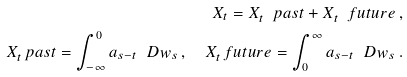<formula> <loc_0><loc_0><loc_500><loc_500>X _ { t } = X _ { t } ^ { \ } p a s t + X _ { t } ^ { \ } f u t u r e \, , \\ X _ { t } ^ { \ } p a s t = \int _ { - \infty } ^ { 0 } a _ { s - t } \, \ D w _ { s } \, , \quad X _ { t } ^ { \ } f u t u r e = \int _ { 0 } ^ { \infty } a _ { s - t } \, \ D w _ { s } \, .</formula> 